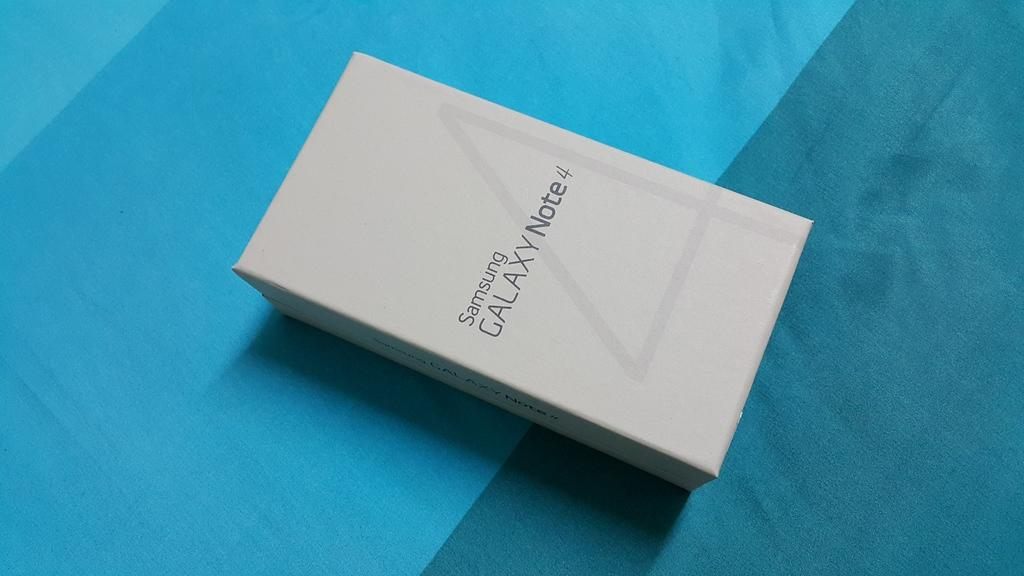<image>
Create a compact narrative representing the image presented. Samsung galaxy note four new in box on a table 